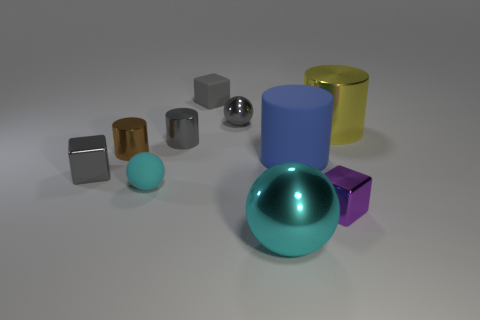Subtract all balls. How many objects are left? 7 Subtract 1 purple blocks. How many objects are left? 9 Subtract all big yellow shiny cubes. Subtract all brown metallic cylinders. How many objects are left? 9 Add 5 gray cylinders. How many gray cylinders are left? 6 Add 8 blue things. How many blue things exist? 9 